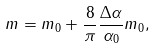<formula> <loc_0><loc_0><loc_500><loc_500>m = m _ { 0 } + \frac { 8 } { \pi } \frac { \Delta \alpha } { \alpha _ { 0 } } m _ { 0 } ,</formula> 